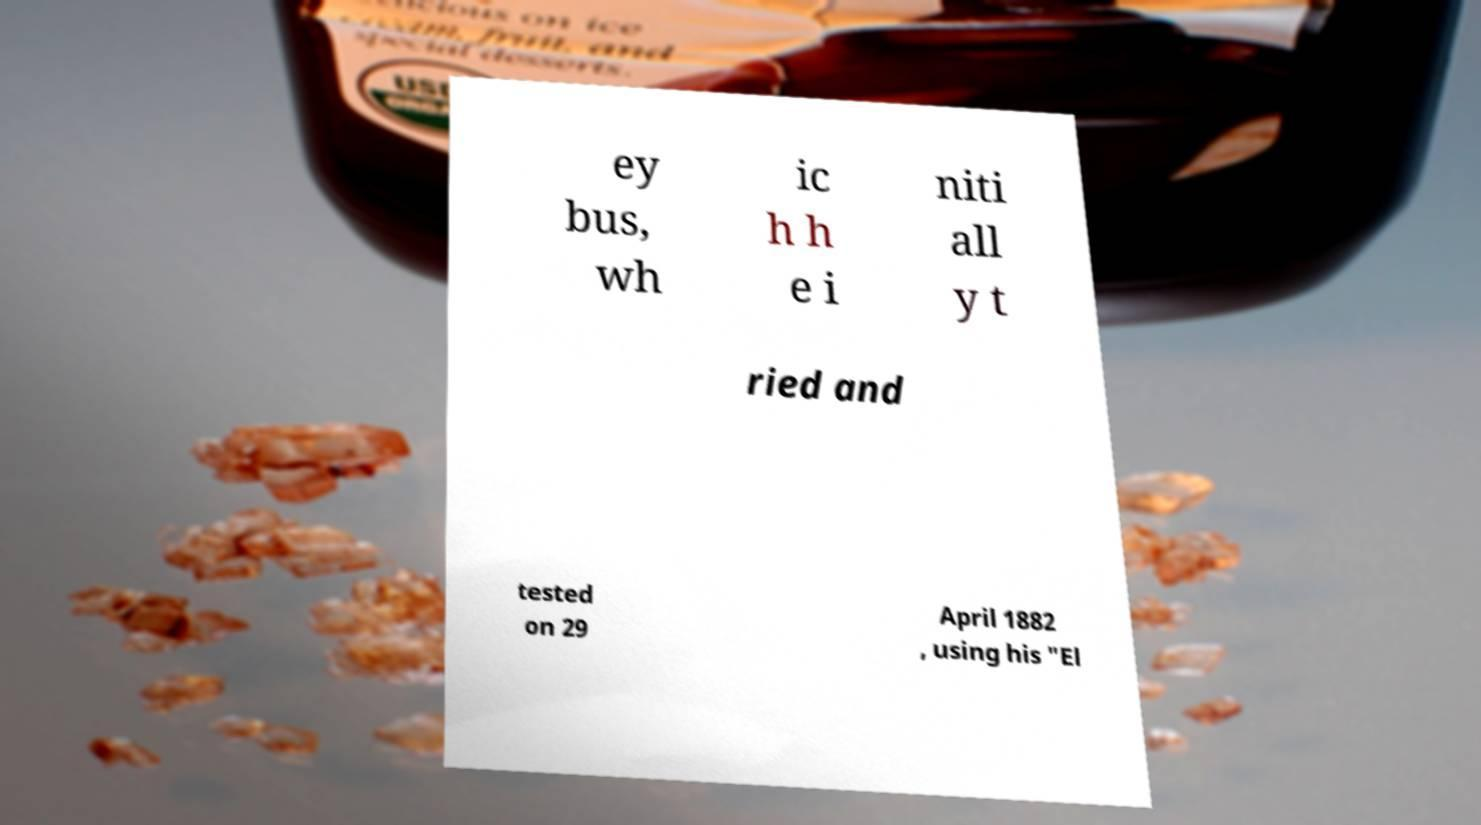What messages or text are displayed in this image? I need them in a readable, typed format. ey bus, wh ic h h e i niti all y t ried and tested on 29 April 1882 , using his "El 